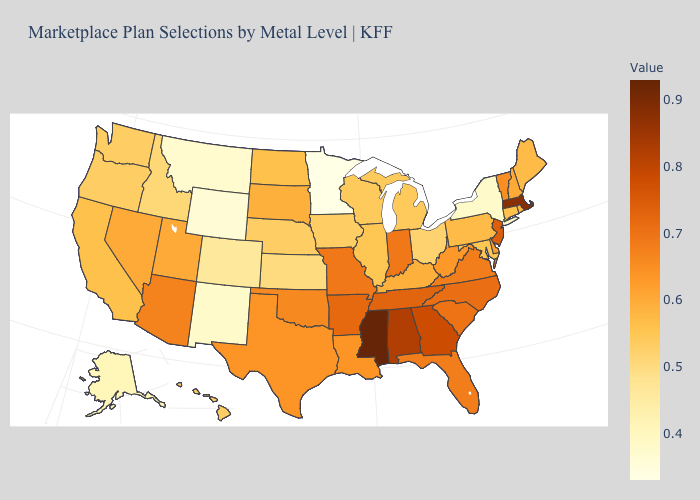Does Mississippi have the highest value in the USA?
Answer briefly. Yes. Among the states that border Illinois , which have the highest value?
Give a very brief answer. Indiana, Missouri. Among the states that border Idaho , does Wyoming have the highest value?
Be succinct. No. 